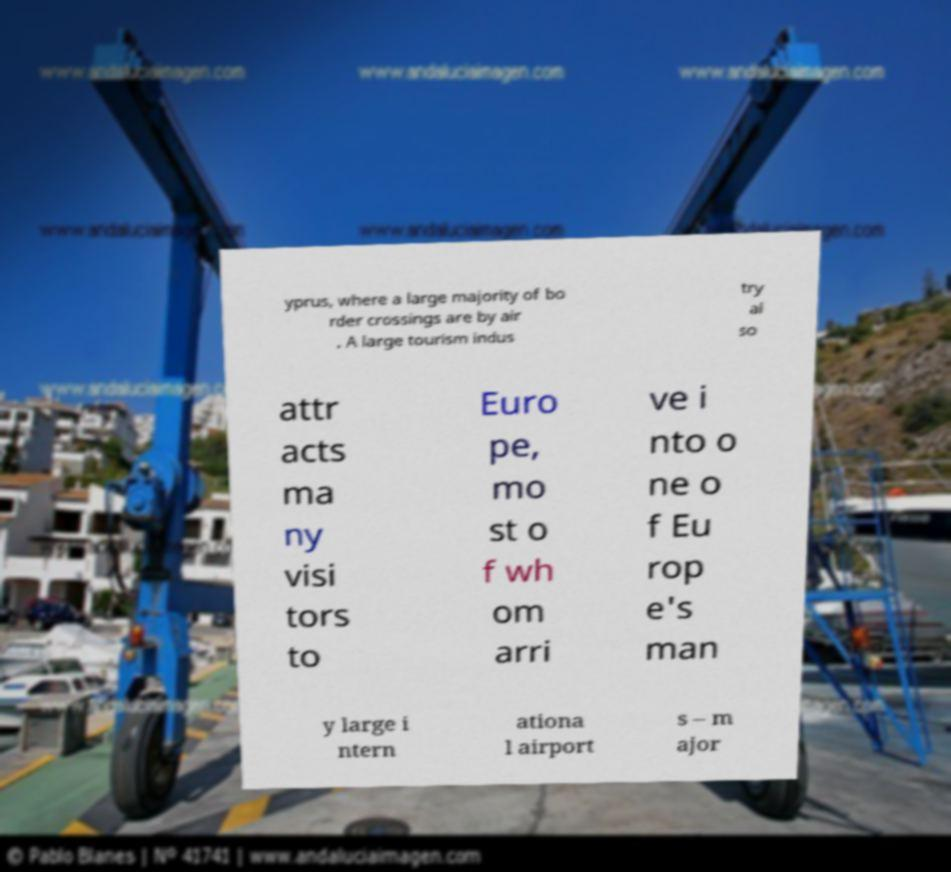Please read and relay the text visible in this image. What does it say? yprus, where a large majority of bo rder crossings are by air . A large tourism indus try al so attr acts ma ny visi tors to Euro pe, mo st o f wh om arri ve i nto o ne o f Eu rop e's man y large i ntern ationa l airport s – m ajor 